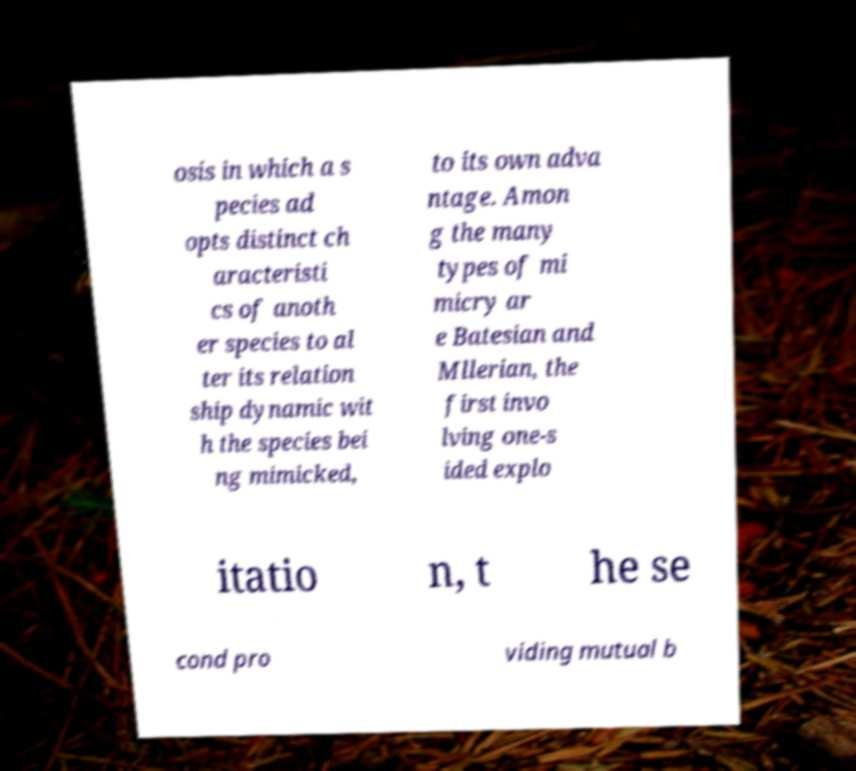Can you accurately transcribe the text from the provided image for me? osis in which a s pecies ad opts distinct ch aracteristi cs of anoth er species to al ter its relation ship dynamic wit h the species bei ng mimicked, to its own adva ntage. Amon g the many types of mi micry ar e Batesian and Mllerian, the first invo lving one-s ided explo itatio n, t he se cond pro viding mutual b 